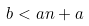Convert formula to latex. <formula><loc_0><loc_0><loc_500><loc_500>b < a n + a</formula> 